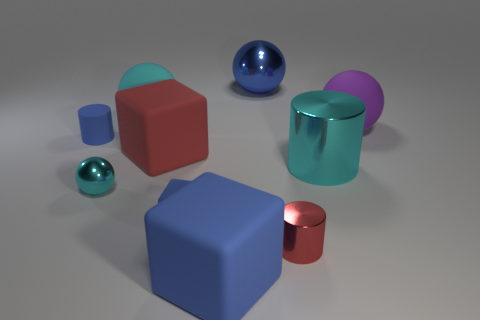What material is the big thing that is the same color as the large shiny sphere?
Make the answer very short. Rubber. What is the size of the ball that is the same color as the small rubber cylinder?
Make the answer very short. Large. There is a cyan metal ball; does it have the same size as the metallic object that is behind the blue matte cylinder?
Provide a succinct answer. No. What number of things are either blue rubber cylinders or cyan things?
Keep it short and to the point. 4. What number of large rubber things are the same color as the tiny cube?
Ensure brevity in your answer.  1. What shape is the metallic thing that is the same size as the cyan shiny ball?
Your answer should be very brief. Cylinder. Is there a small green metallic thing that has the same shape as the blue metal object?
Offer a terse response. No. What number of large cubes have the same material as the blue cylinder?
Offer a very short reply. 2. Does the cyan object behind the purple matte object have the same material as the tiny blue block?
Ensure brevity in your answer.  Yes. Is the number of red rubber blocks that are behind the purple matte sphere greater than the number of cyan spheres that are right of the small red thing?
Your response must be concise. No. 